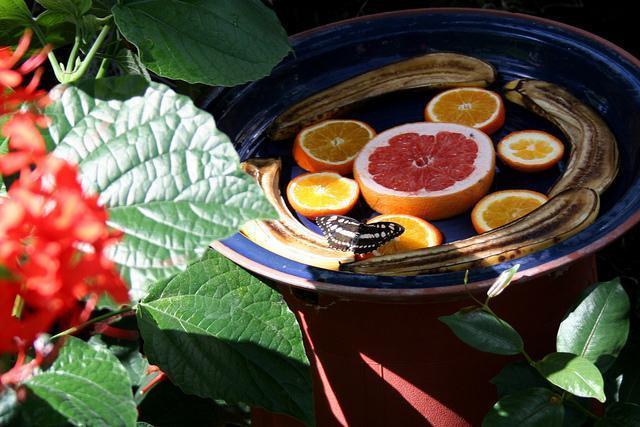How many different kinds of fruit are in the bowl?
Give a very brief answer. 2. How many bananas are there?
Give a very brief answer. 4. How many oranges are in the photo?
Give a very brief answer. 7. 